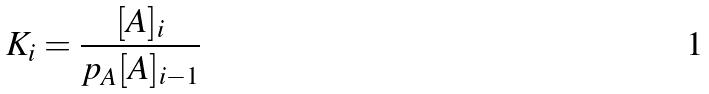<formula> <loc_0><loc_0><loc_500><loc_500>K _ { i } = \frac { [ A ] _ { i } } { p _ { A } [ A ] _ { i - 1 } }</formula> 